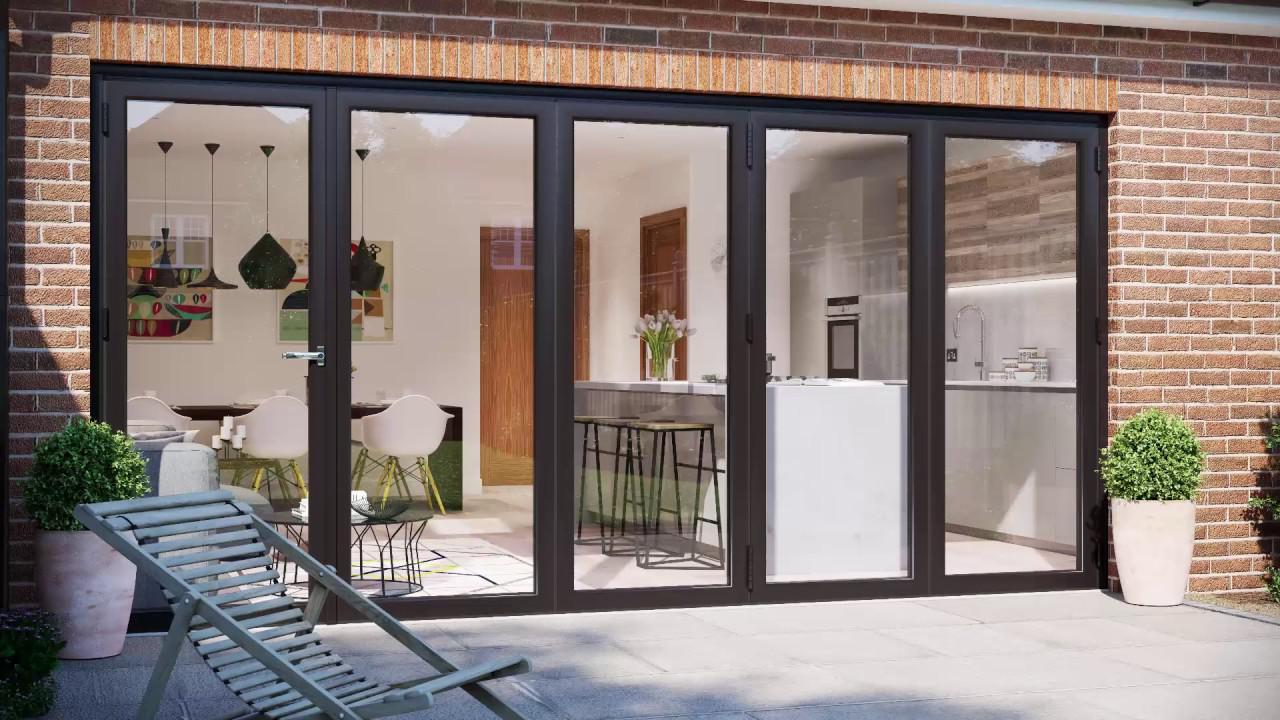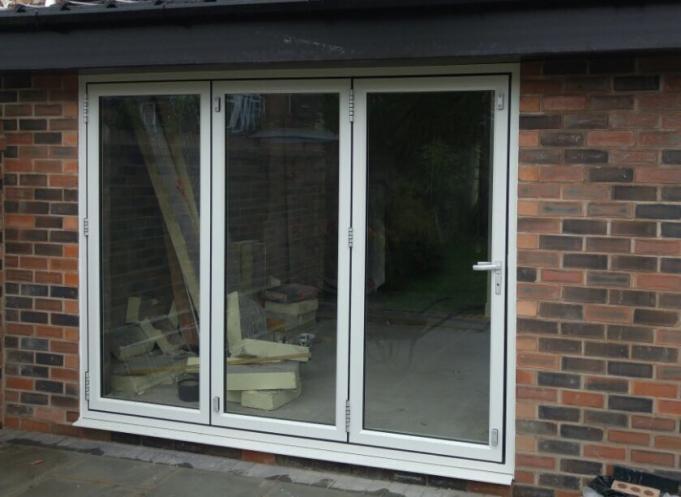The first image is the image on the left, the second image is the image on the right. For the images displayed, is the sentence "The doors in the left image are closed." factually correct? Answer yes or no. Yes. The first image is the image on the left, the second image is the image on the right. Examine the images to the left and right. Is the description "An image shows a glass door unit with at least three panels and with a handle on the rightmost door, flanked by bricks of different colors and viewed at an angle." accurate? Answer yes or no. Yes. 